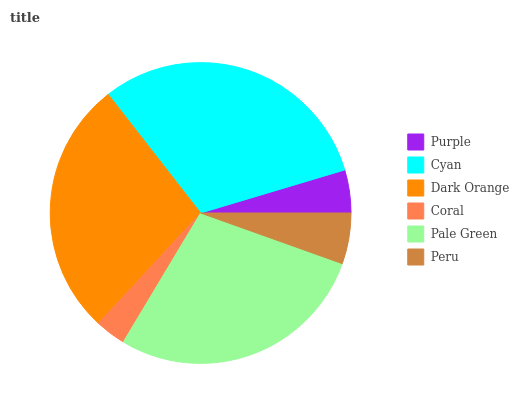Is Coral the minimum?
Answer yes or no. Yes. Is Cyan the maximum?
Answer yes or no. Yes. Is Dark Orange the minimum?
Answer yes or no. No. Is Dark Orange the maximum?
Answer yes or no. No. Is Cyan greater than Dark Orange?
Answer yes or no. Yes. Is Dark Orange less than Cyan?
Answer yes or no. Yes. Is Dark Orange greater than Cyan?
Answer yes or no. No. Is Cyan less than Dark Orange?
Answer yes or no. No. Is Dark Orange the high median?
Answer yes or no. Yes. Is Peru the low median?
Answer yes or no. Yes. Is Purple the high median?
Answer yes or no. No. Is Purple the low median?
Answer yes or no. No. 